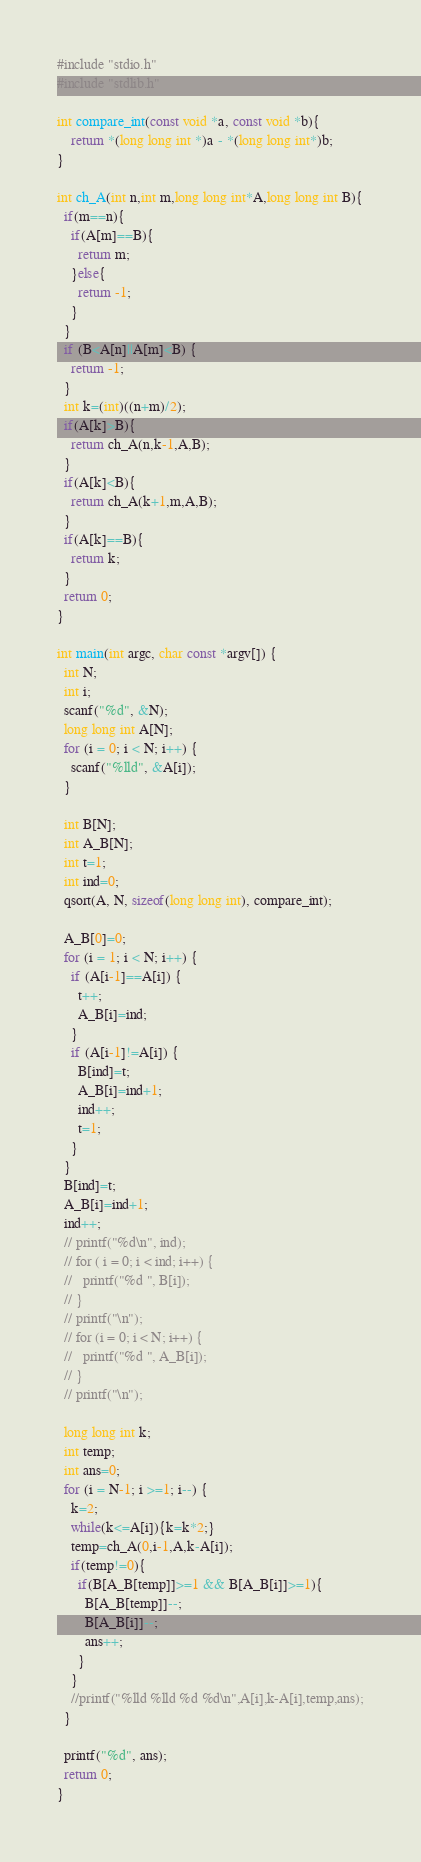Convert code to text. <code><loc_0><loc_0><loc_500><loc_500><_C_>#include "stdio.h"
#include "stdlib.h"

int compare_int(const void *a, const void *b){
    return *(long long int *)a - *(long long int*)b;
}

int ch_A(int n,int m,long long int*A,long long int B){
  if(m==n){
    if(A[m]==B){
      return m;
    }else{
      return -1;
    }
  }
  if (B<A[n]||A[m]<B) {
    return -1;
  }
  int k=(int)((n+m)/2);
  if(A[k]>B){
    return ch_A(n,k-1,A,B);
  }
  if(A[k]<B){
    return ch_A(k+1,m,A,B);
  }
  if(A[k]==B){
    return k;
  }
  return 0;
}

int main(int argc, char const *argv[]) {
  int N;
  int i;
  scanf("%d", &N);
  long long int A[N];
  for (i = 0; i < N; i++) {
    scanf("%lld", &A[i]);
  }

  int B[N];
  int A_B[N];
  int t=1;
  int ind=0;
  qsort(A, N, sizeof(long long int), compare_int);

  A_B[0]=0;
  for (i = 1; i < N; i++) {
    if (A[i-1]==A[i]) {
      t++;
      A_B[i]=ind;
    }
    if (A[i-1]!=A[i]) {
      B[ind]=t;
      A_B[i]=ind+1;
      ind++;
      t=1;
    }
  }
  B[ind]=t;
  A_B[i]=ind+1;
  ind++;
  // printf("%d\n", ind);
  // for ( i = 0; i < ind; i++) {
  //   printf("%d ", B[i]);
  // }
  // printf("\n");
  // for (i = 0; i < N; i++) {
  //   printf("%d ", A_B[i]);
  // }
  // printf("\n");

  long long int k;
  int temp;
  int ans=0;
  for (i = N-1; i >=1; i--) {
    k=2;
    while(k<=A[i]){k=k*2;}
    temp=ch_A(0,i-1,A,k-A[i]);
    if(temp!=0){
      if(B[A_B[temp]]>=1 && B[A_B[i]]>=1){
        B[A_B[temp]]--;
        B[A_B[i]]--;
        ans++;
      }
    }
    //printf("%lld %lld %d %d\n",A[i],k-A[i],temp,ans);
  }

  printf("%d", ans);
  return 0;
}
</code> 